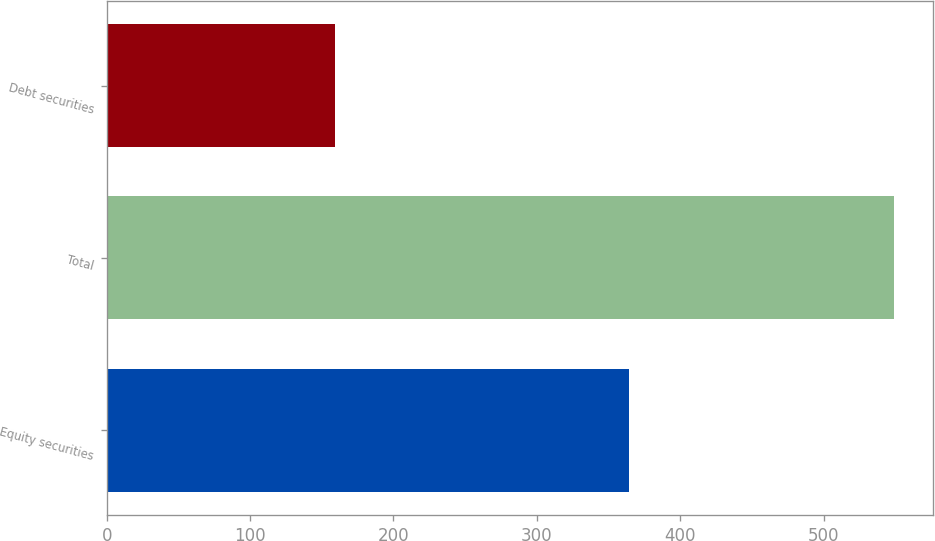<chart> <loc_0><loc_0><loc_500><loc_500><bar_chart><fcel>Equity securities<fcel>Total<fcel>Debt securities<nl><fcel>364<fcel>549<fcel>159<nl></chart> 